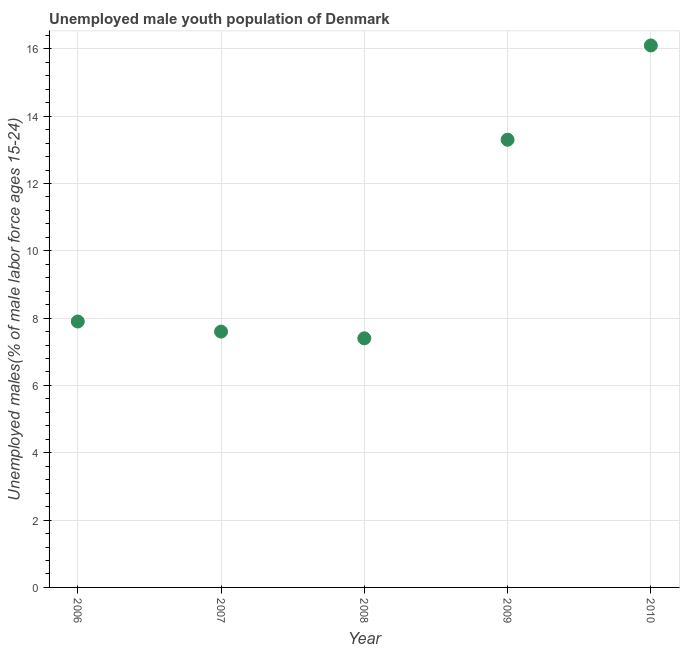What is the unemployed male youth in 2010?
Offer a terse response. 16.1. Across all years, what is the maximum unemployed male youth?
Offer a terse response. 16.1. Across all years, what is the minimum unemployed male youth?
Keep it short and to the point. 7.4. In which year was the unemployed male youth maximum?
Make the answer very short. 2010. What is the sum of the unemployed male youth?
Provide a succinct answer. 52.3. What is the difference between the unemployed male youth in 2006 and 2009?
Provide a short and direct response. -5.4. What is the average unemployed male youth per year?
Your answer should be very brief. 10.46. What is the median unemployed male youth?
Ensure brevity in your answer.  7.9. What is the ratio of the unemployed male youth in 2007 to that in 2009?
Your response must be concise. 0.57. Is the unemployed male youth in 2006 less than that in 2007?
Offer a very short reply. No. What is the difference between the highest and the second highest unemployed male youth?
Give a very brief answer. 2.8. What is the difference between the highest and the lowest unemployed male youth?
Provide a short and direct response. 8.7. In how many years, is the unemployed male youth greater than the average unemployed male youth taken over all years?
Your response must be concise. 2. Does the unemployed male youth monotonically increase over the years?
Offer a very short reply. No. How many dotlines are there?
Offer a terse response. 1. How many years are there in the graph?
Your answer should be compact. 5. What is the difference between two consecutive major ticks on the Y-axis?
Offer a terse response. 2. Does the graph contain any zero values?
Provide a succinct answer. No. What is the title of the graph?
Provide a short and direct response. Unemployed male youth population of Denmark. What is the label or title of the X-axis?
Provide a short and direct response. Year. What is the label or title of the Y-axis?
Keep it short and to the point. Unemployed males(% of male labor force ages 15-24). What is the Unemployed males(% of male labor force ages 15-24) in 2006?
Give a very brief answer. 7.9. What is the Unemployed males(% of male labor force ages 15-24) in 2007?
Provide a succinct answer. 7.6. What is the Unemployed males(% of male labor force ages 15-24) in 2008?
Your answer should be very brief. 7.4. What is the Unemployed males(% of male labor force ages 15-24) in 2009?
Your response must be concise. 13.3. What is the Unemployed males(% of male labor force ages 15-24) in 2010?
Offer a terse response. 16.1. What is the difference between the Unemployed males(% of male labor force ages 15-24) in 2006 and 2007?
Offer a very short reply. 0.3. What is the difference between the Unemployed males(% of male labor force ages 15-24) in 2006 and 2008?
Give a very brief answer. 0.5. What is the difference between the Unemployed males(% of male labor force ages 15-24) in 2006 and 2010?
Give a very brief answer. -8.2. What is the difference between the Unemployed males(% of male labor force ages 15-24) in 2007 and 2010?
Ensure brevity in your answer.  -8.5. What is the difference between the Unemployed males(% of male labor force ages 15-24) in 2008 and 2009?
Provide a succinct answer. -5.9. What is the difference between the Unemployed males(% of male labor force ages 15-24) in 2008 and 2010?
Offer a very short reply. -8.7. What is the ratio of the Unemployed males(% of male labor force ages 15-24) in 2006 to that in 2007?
Your response must be concise. 1.04. What is the ratio of the Unemployed males(% of male labor force ages 15-24) in 2006 to that in 2008?
Provide a succinct answer. 1.07. What is the ratio of the Unemployed males(% of male labor force ages 15-24) in 2006 to that in 2009?
Your answer should be very brief. 0.59. What is the ratio of the Unemployed males(% of male labor force ages 15-24) in 2006 to that in 2010?
Offer a terse response. 0.49. What is the ratio of the Unemployed males(% of male labor force ages 15-24) in 2007 to that in 2009?
Make the answer very short. 0.57. What is the ratio of the Unemployed males(% of male labor force ages 15-24) in 2007 to that in 2010?
Provide a succinct answer. 0.47. What is the ratio of the Unemployed males(% of male labor force ages 15-24) in 2008 to that in 2009?
Your answer should be very brief. 0.56. What is the ratio of the Unemployed males(% of male labor force ages 15-24) in 2008 to that in 2010?
Your response must be concise. 0.46. What is the ratio of the Unemployed males(% of male labor force ages 15-24) in 2009 to that in 2010?
Offer a very short reply. 0.83. 